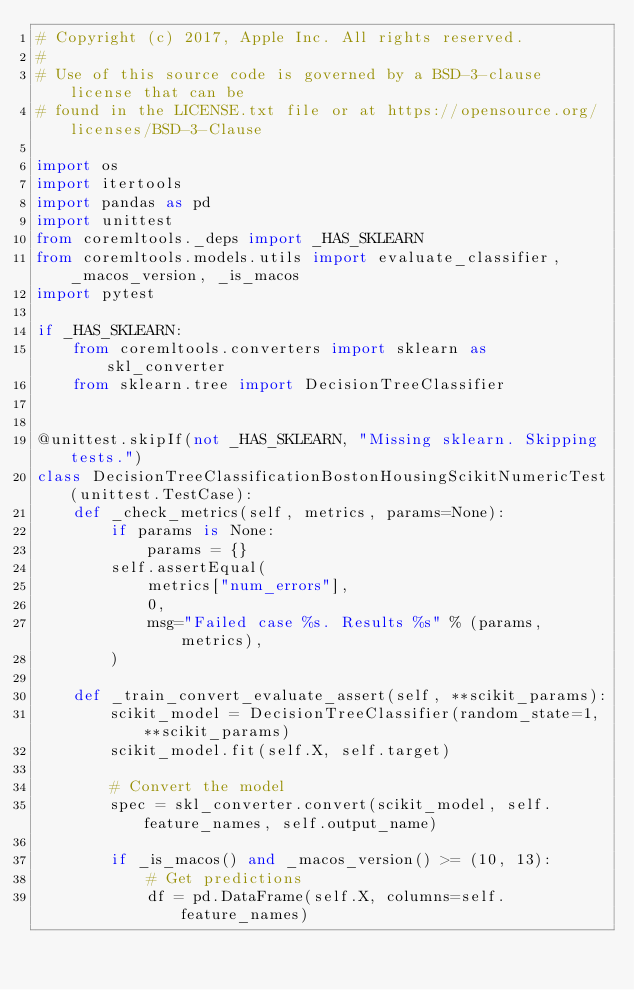Convert code to text. <code><loc_0><loc_0><loc_500><loc_500><_Python_># Copyright (c) 2017, Apple Inc. All rights reserved.
#
# Use of this source code is governed by a BSD-3-clause license that can be
# found in the LICENSE.txt file or at https://opensource.org/licenses/BSD-3-Clause

import os
import itertools
import pandas as pd
import unittest
from coremltools._deps import _HAS_SKLEARN
from coremltools.models.utils import evaluate_classifier, _macos_version, _is_macos
import pytest

if _HAS_SKLEARN:
    from coremltools.converters import sklearn as skl_converter
    from sklearn.tree import DecisionTreeClassifier


@unittest.skipIf(not _HAS_SKLEARN, "Missing sklearn. Skipping tests.")
class DecisionTreeClassificationBostonHousingScikitNumericTest(unittest.TestCase):
    def _check_metrics(self, metrics, params=None):
        if params is None:
            params = {}
        self.assertEqual(
            metrics["num_errors"],
            0,
            msg="Failed case %s. Results %s" % (params, metrics),
        )

    def _train_convert_evaluate_assert(self, **scikit_params):
        scikit_model = DecisionTreeClassifier(random_state=1, **scikit_params)
        scikit_model.fit(self.X, self.target)

        # Convert the model
        spec = skl_converter.convert(scikit_model, self.feature_names, self.output_name)

        if _is_macos() and _macos_version() >= (10, 13):
            # Get predictions
            df = pd.DataFrame(self.X, columns=self.feature_names)</code> 